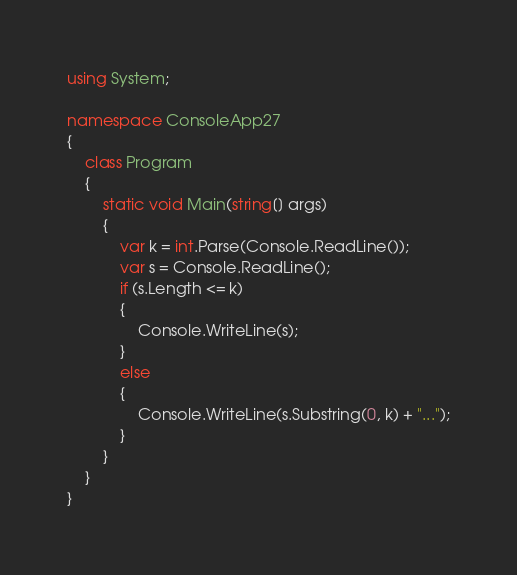<code> <loc_0><loc_0><loc_500><loc_500><_C#_>using System;

namespace ConsoleApp27
{
    class Program
    {
        static void Main(string[] args)
        {
            var k = int.Parse(Console.ReadLine());
            var s = Console.ReadLine();
            if (s.Length <= k)
            {
                Console.WriteLine(s);
            }
            else
            {
                Console.WriteLine(s.Substring(0, k) + "...");
            }
        }
    }
}
</code> 